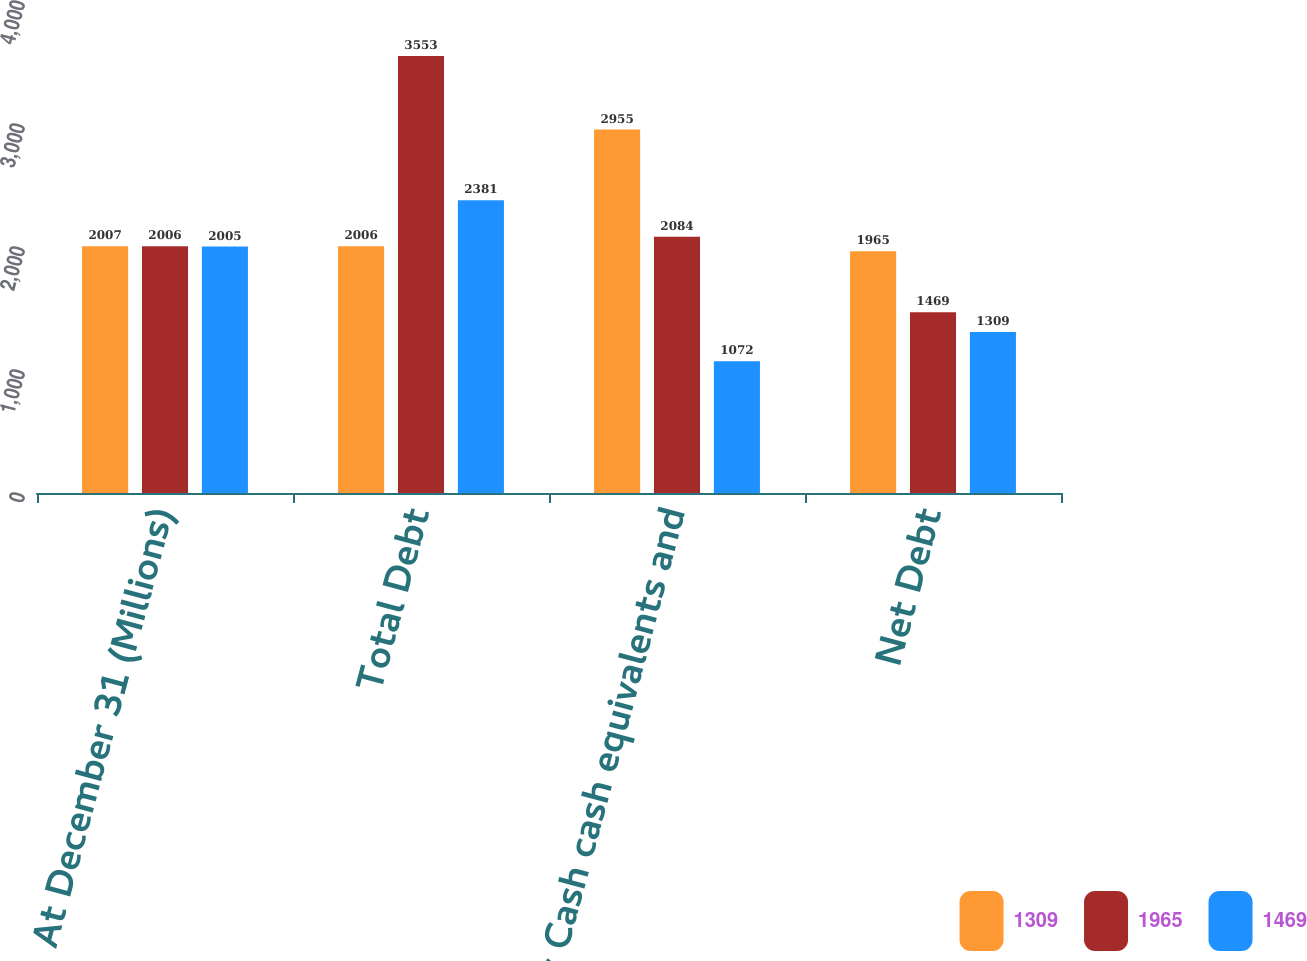Convert chart. <chart><loc_0><loc_0><loc_500><loc_500><stacked_bar_chart><ecel><fcel>At December 31 (Millions)<fcel>Total Debt<fcel>Less Cash cash equivalents and<fcel>Net Debt<nl><fcel>1309<fcel>2007<fcel>2006<fcel>2955<fcel>1965<nl><fcel>1965<fcel>2006<fcel>3553<fcel>2084<fcel>1469<nl><fcel>1469<fcel>2005<fcel>2381<fcel>1072<fcel>1309<nl></chart> 